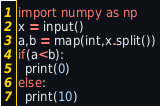Convert code to text. <code><loc_0><loc_0><loc_500><loc_500><_Python_>import numpy as np
x = input()
a,b = map(int,x.split())
if(a<b):
  print(0)
else:
  print(10)</code> 